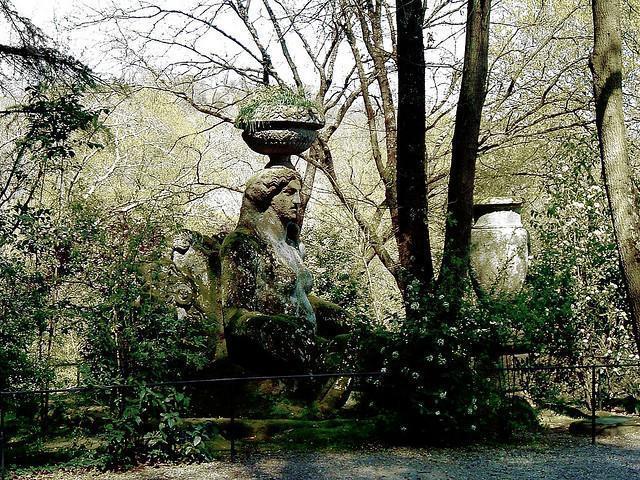How many statues are in this park?
Give a very brief answer. 2. 